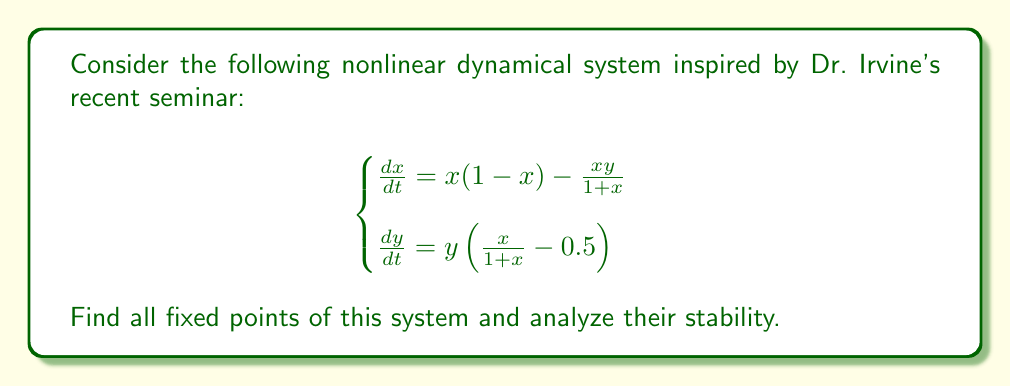Can you solve this math problem? 1. Find the fixed points:
   Set $\frac{dx}{dt} = 0$ and $\frac{dy}{dt} = 0$

   From $\frac{dy}{dt} = 0$:
   $y = 0$ or $\frac{x}{1+x} = 0.5$
   Solving $\frac{x}{1+x} = 0.5$, we get $x = 1$

   From $\frac{dx}{dt} = 0$ with $y = 0$:
   $x(1-x) = 0$, so $x = 0$ or $x = 1$

   Therefore, the fixed points are $(0,0)$ and $(1,0)$

2. Analyze stability:
   Calculate the Jacobian matrix:
   $$J = \begin{bmatrix}
   1-2x-\frac{y}{(1+x)^2} & -\frac{x}{1+x} \\
   \frac{y}{(1+x)^2} & \frac{x}{1+x}-0.5
   \end{bmatrix}$$

3. Evaluate Jacobian at $(0,0)$:
   $$J_{(0,0)} = \begin{bmatrix}
   1 & 0 \\
   0 & -0.5
   \end{bmatrix}$$
   Eigenvalues: $\lambda_1 = 1$, $\lambda_2 = -0.5$
   Since $\lambda_1 > 0$, $(0,0)$ is an unstable saddle point.

4. Evaluate Jacobian at $(1,0)$:
   $$J_{(1,0)} = \begin{bmatrix}
   -1 & -0.5 \\
   0 & 0
   \end{bmatrix}$$
   Eigenvalues: $\lambda_1 = -1$, $\lambda_2 = 0$
   Since $\lambda_2 = 0$, we cannot determine stability from linearization alone. Further analysis (e.g., center manifold theory) is needed.
Answer: $(0,0)$ is an unstable saddle point; $(1,0)$ requires further analysis. 